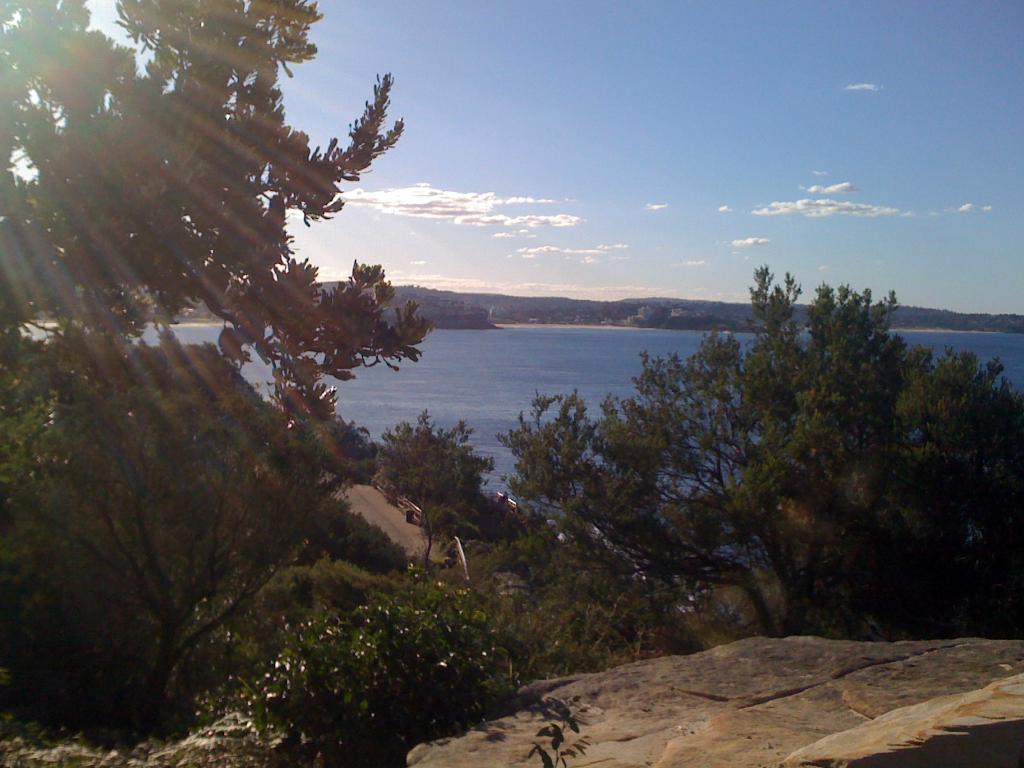Please provide a concise description of this image. This picture is taken from outside of the city. In this image, on the left side, we can see some trees and plants. On the right side, we can also see some trees and plants. In the background, we can see water in a lake, trees. At the top, we can see a sky, at the bottom, we can see some plants and rocks. 